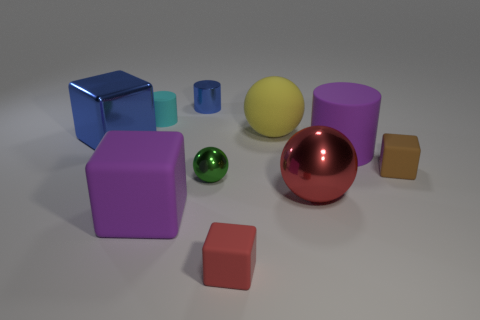Is the number of tiny cyan rubber cylinders right of the purple cube the same as the number of yellow balls?
Make the answer very short. No. Is there a small metal cube that has the same color as the large matte cylinder?
Offer a very short reply. No. Do the yellow ball and the cyan rubber cylinder have the same size?
Provide a succinct answer. No. There is a object behind the tiny rubber cylinder that is to the left of the tiny red rubber cube; what size is it?
Your answer should be compact. Small. How big is the metal object that is both behind the green metallic object and in front of the blue cylinder?
Offer a very short reply. Large. What number of brown objects are the same size as the purple matte cylinder?
Your answer should be compact. 0. How many rubber things are brown cubes or cyan objects?
Make the answer very short. 2. The metallic thing that is the same color as the big metallic block is what size?
Your response must be concise. Small. What is the material of the small block that is right of the large purple object to the right of the large purple cube?
Your answer should be compact. Rubber. What number of objects are gray metallic cylinders or tiny metal things in front of the metallic cylinder?
Provide a succinct answer. 1. 